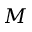Convert formula to latex. <formula><loc_0><loc_0><loc_500><loc_500>M</formula> 